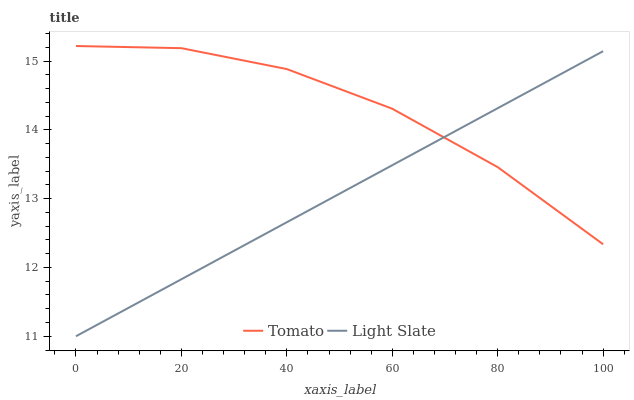Does Light Slate have the minimum area under the curve?
Answer yes or no. Yes. Does Tomato have the maximum area under the curve?
Answer yes or no. Yes. Does Light Slate have the maximum area under the curve?
Answer yes or no. No. Is Light Slate the smoothest?
Answer yes or no. Yes. Is Tomato the roughest?
Answer yes or no. Yes. Is Light Slate the roughest?
Answer yes or no. No. Does Light Slate have the lowest value?
Answer yes or no. Yes. Does Tomato have the highest value?
Answer yes or no. Yes. Does Light Slate have the highest value?
Answer yes or no. No. Does Light Slate intersect Tomato?
Answer yes or no. Yes. Is Light Slate less than Tomato?
Answer yes or no. No. Is Light Slate greater than Tomato?
Answer yes or no. No. 